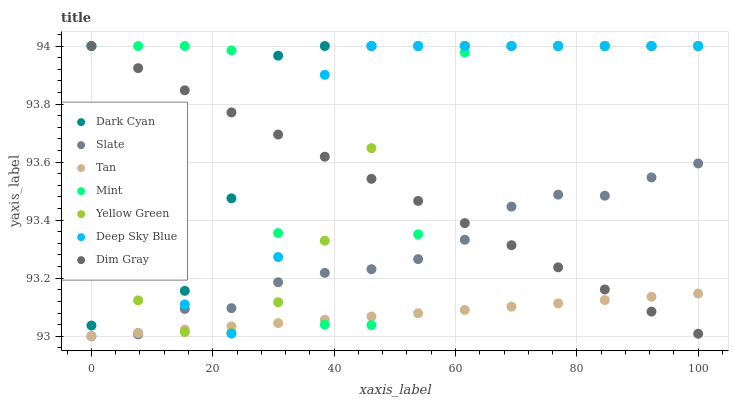Does Tan have the minimum area under the curve?
Answer yes or no. Yes. Does Dark Cyan have the maximum area under the curve?
Answer yes or no. Yes. Does Yellow Green have the minimum area under the curve?
Answer yes or no. No. Does Yellow Green have the maximum area under the curve?
Answer yes or no. No. Is Dim Gray the smoothest?
Answer yes or no. Yes. Is Mint the roughest?
Answer yes or no. Yes. Is Yellow Green the smoothest?
Answer yes or no. No. Is Yellow Green the roughest?
Answer yes or no. No. Does Slate have the lowest value?
Answer yes or no. Yes. Does Yellow Green have the lowest value?
Answer yes or no. No. Does Mint have the highest value?
Answer yes or no. Yes. Does Slate have the highest value?
Answer yes or no. No. Is Slate less than Dark Cyan?
Answer yes or no. Yes. Is Dark Cyan greater than Slate?
Answer yes or no. Yes. Does Slate intersect Mint?
Answer yes or no. Yes. Is Slate less than Mint?
Answer yes or no. No. Is Slate greater than Mint?
Answer yes or no. No. Does Slate intersect Dark Cyan?
Answer yes or no. No. 